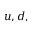<formula> <loc_0><loc_0><loc_500><loc_500>u , d ,</formula> 